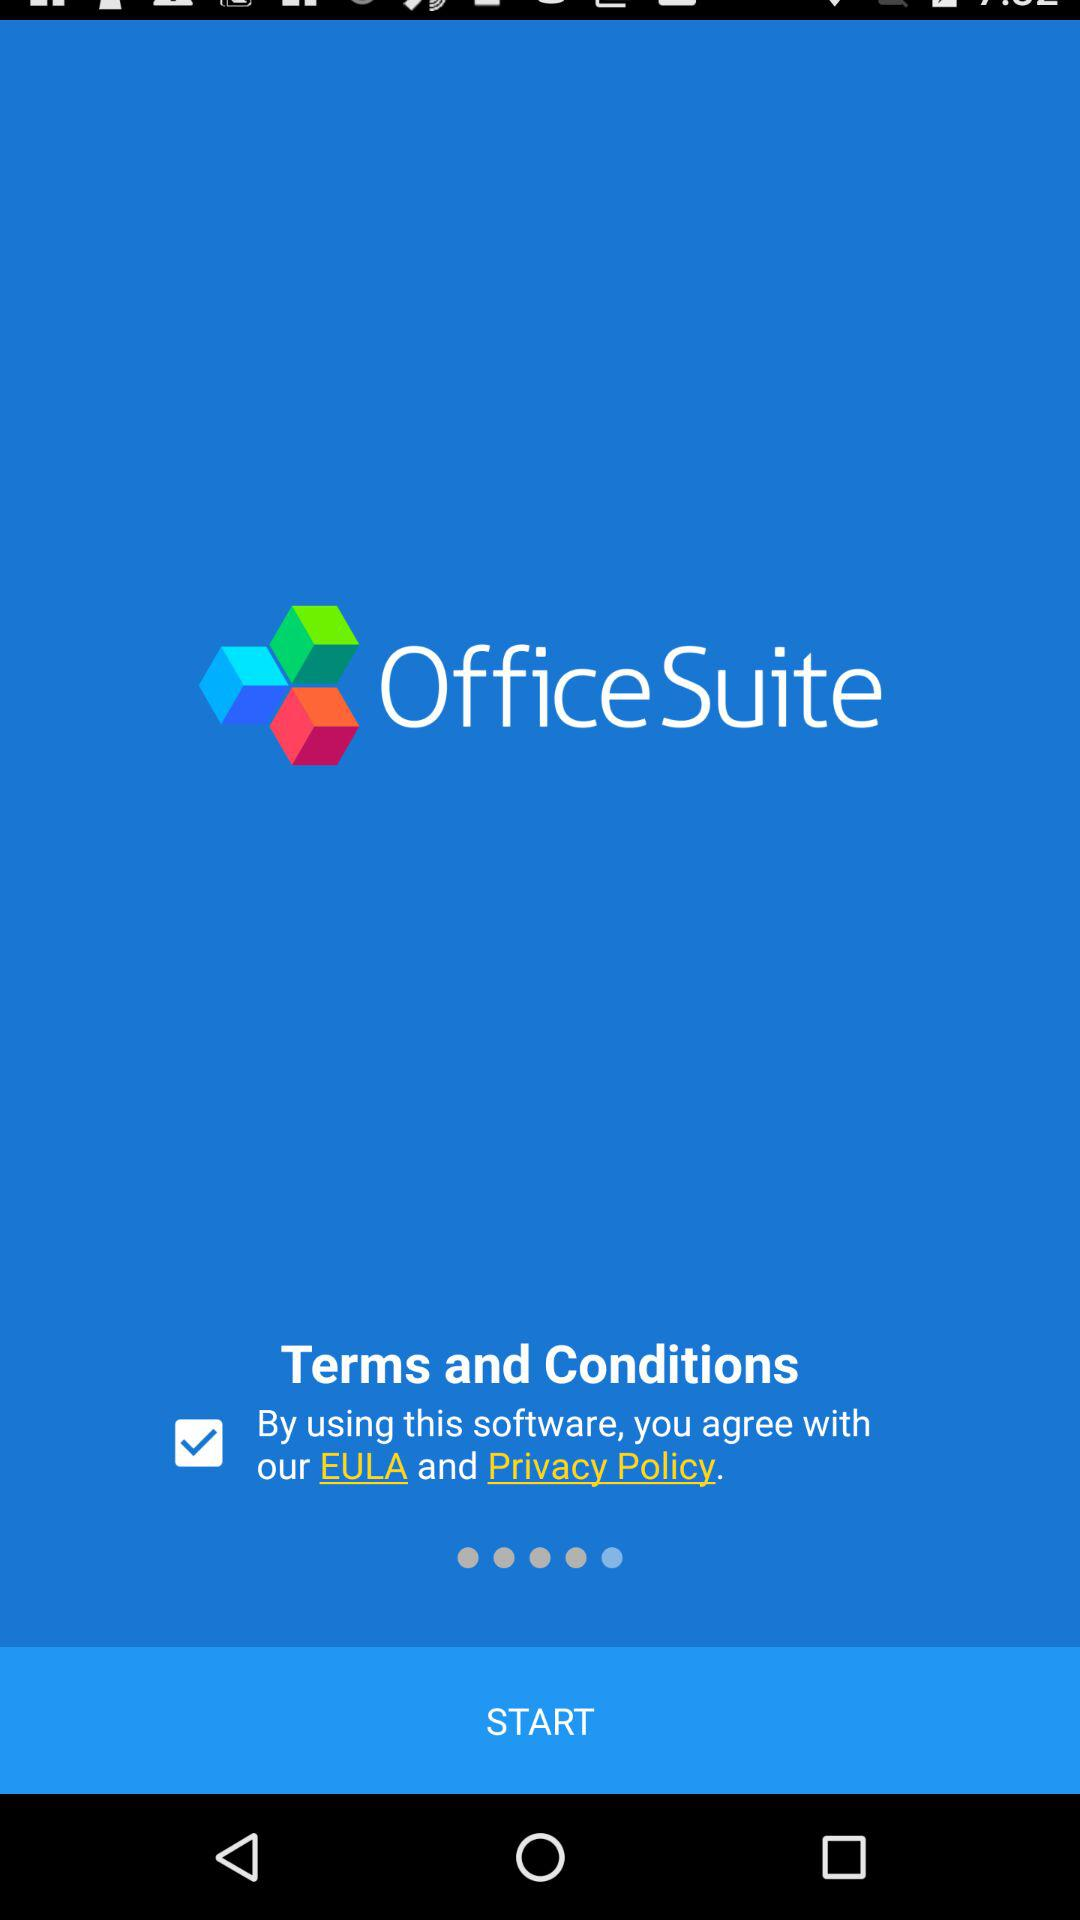What is the name of the application? The name of the application is "OfficeSuite". 